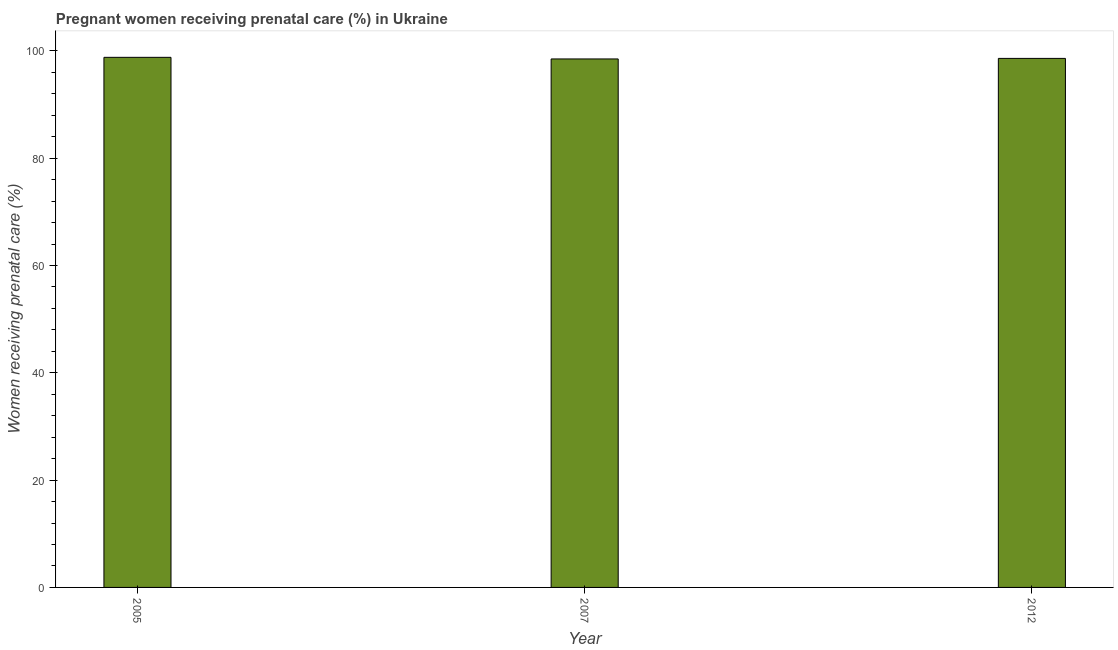Does the graph contain any zero values?
Your answer should be compact. No. What is the title of the graph?
Provide a succinct answer. Pregnant women receiving prenatal care (%) in Ukraine. What is the label or title of the X-axis?
Give a very brief answer. Year. What is the label or title of the Y-axis?
Ensure brevity in your answer.  Women receiving prenatal care (%). What is the percentage of pregnant women receiving prenatal care in 2012?
Offer a terse response. 98.6. Across all years, what is the maximum percentage of pregnant women receiving prenatal care?
Offer a terse response. 98.8. Across all years, what is the minimum percentage of pregnant women receiving prenatal care?
Offer a terse response. 98.5. What is the sum of the percentage of pregnant women receiving prenatal care?
Keep it short and to the point. 295.9. What is the difference between the percentage of pregnant women receiving prenatal care in 2007 and 2012?
Offer a terse response. -0.1. What is the average percentage of pregnant women receiving prenatal care per year?
Offer a terse response. 98.63. What is the median percentage of pregnant women receiving prenatal care?
Your answer should be very brief. 98.6. Is the percentage of pregnant women receiving prenatal care in 2005 less than that in 2012?
Provide a succinct answer. No. Is the difference between the percentage of pregnant women receiving prenatal care in 2005 and 2012 greater than the difference between any two years?
Provide a short and direct response. No. Is the sum of the percentage of pregnant women receiving prenatal care in 2007 and 2012 greater than the maximum percentage of pregnant women receiving prenatal care across all years?
Your answer should be very brief. Yes. How many bars are there?
Your answer should be compact. 3. How many years are there in the graph?
Make the answer very short. 3. What is the difference between two consecutive major ticks on the Y-axis?
Ensure brevity in your answer.  20. What is the Women receiving prenatal care (%) in 2005?
Ensure brevity in your answer.  98.8. What is the Women receiving prenatal care (%) of 2007?
Make the answer very short. 98.5. What is the Women receiving prenatal care (%) in 2012?
Your answer should be very brief. 98.6. What is the ratio of the Women receiving prenatal care (%) in 2005 to that in 2007?
Keep it short and to the point. 1. What is the ratio of the Women receiving prenatal care (%) in 2005 to that in 2012?
Keep it short and to the point. 1. 